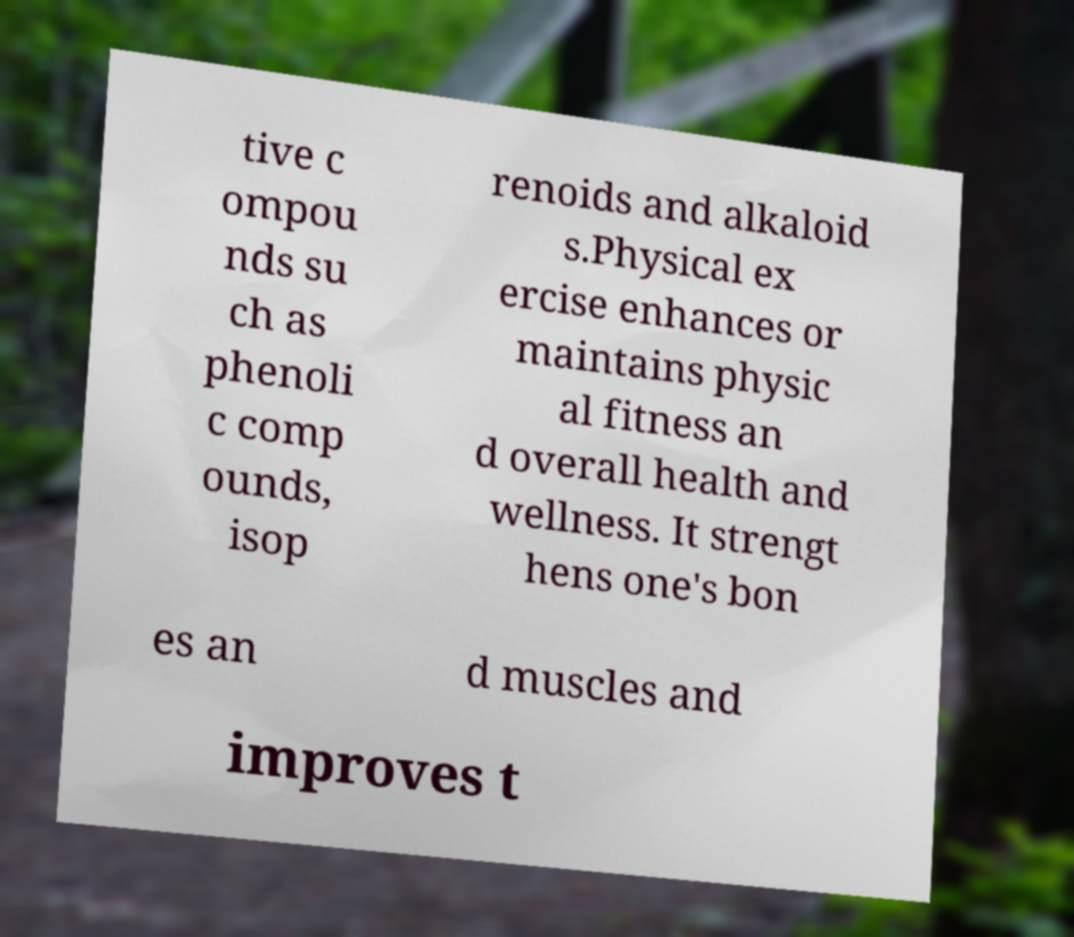Could you assist in decoding the text presented in this image and type it out clearly? tive c ompou nds su ch as phenoli c comp ounds, isop renoids and alkaloid s.Physical ex ercise enhances or maintains physic al fitness an d overall health and wellness. It strengt hens one's bon es an d muscles and improves t 